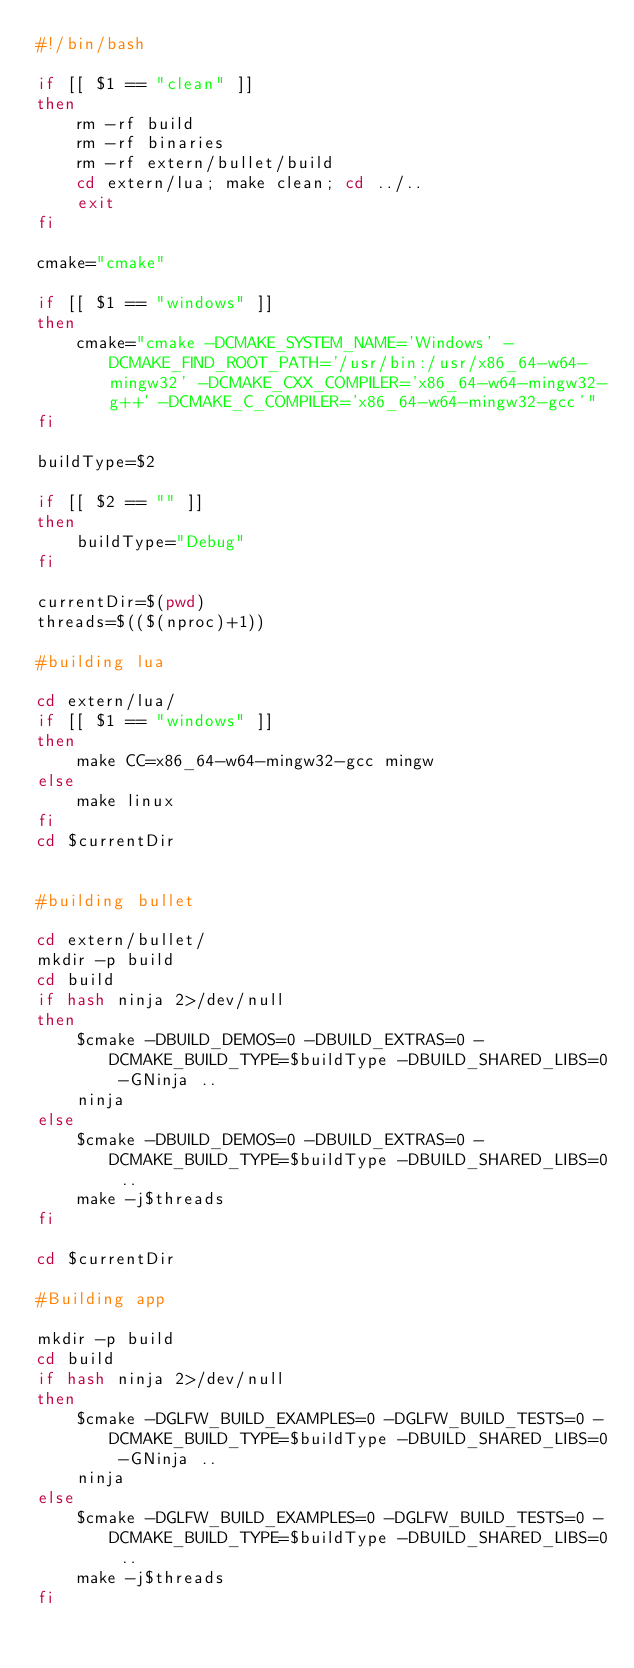Convert code to text. <code><loc_0><loc_0><loc_500><loc_500><_Bash_>#!/bin/bash

if [[ $1 == "clean" ]]
then
    rm -rf build
    rm -rf binaries
    rm -rf extern/bullet/build
    cd extern/lua; make clean; cd ../..
    exit
fi

cmake="cmake"

if [[ $1 == "windows" ]]
then
    cmake="cmake -DCMAKE_SYSTEM_NAME='Windows' -DCMAKE_FIND_ROOT_PATH='/usr/bin:/usr/x86_64-w64-mingw32' -DCMAKE_CXX_COMPILER='x86_64-w64-mingw32-g++' -DCMAKE_C_COMPILER='x86_64-w64-mingw32-gcc'"
fi

buildType=$2

if [[ $2 == "" ]]
then
    buildType="Debug"
fi

currentDir=$(pwd)
threads=$(($(nproc)+1))

#building lua

cd extern/lua/
if [[ $1 == "windows" ]]
then
    make CC=x86_64-w64-mingw32-gcc mingw
else
    make linux
fi
cd $currentDir


#building bullet

cd extern/bullet/
mkdir -p build
cd build
if hash ninja 2>/dev/null
then
    $cmake -DBUILD_DEMOS=0 -DBUILD_EXTRAS=0 -DCMAKE_BUILD_TYPE=$buildType -DBUILD_SHARED_LIBS=0 -GNinja ..
    ninja
else
    $cmake -DBUILD_DEMOS=0 -DBUILD_EXTRAS=0 -DCMAKE_BUILD_TYPE=$buildType -DBUILD_SHARED_LIBS=0 ..
    make -j$threads
fi

cd $currentDir

#Building app

mkdir -p build
cd build 
if hash ninja 2>/dev/null
then
    $cmake -DGLFW_BUILD_EXAMPLES=0 -DGLFW_BUILD_TESTS=0 -DCMAKE_BUILD_TYPE=$buildType -DBUILD_SHARED_LIBS=0 -GNinja ..
    ninja
else
    $cmake -DGLFW_BUILD_EXAMPLES=0 -DGLFW_BUILD_TESTS=0 -DCMAKE_BUILD_TYPE=$buildType -DBUILD_SHARED_LIBS=0 ..
    make -j$threads
fi
</code> 